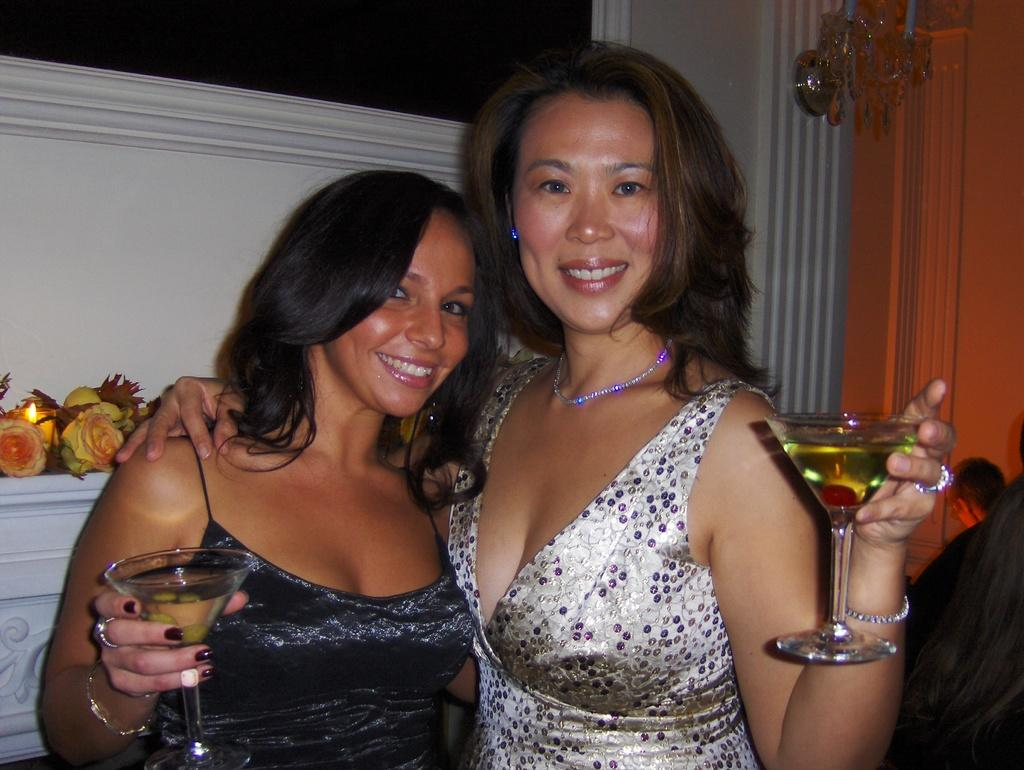How many people are in the image? There are two ladies in the image. What are the ladies doing in the image? The ladies are standing and smiling. What are the ladies holding in the image? The ladies are holding two glasses. What can be seen in the background of the image? There are flowers, a wall, and decorating items in the background of the image. Can you see any fog in the image? No, there is no fog present in the image. Is there a father in the image? The provided facts do not mention a father, so we cannot determine if there is one in the image. 